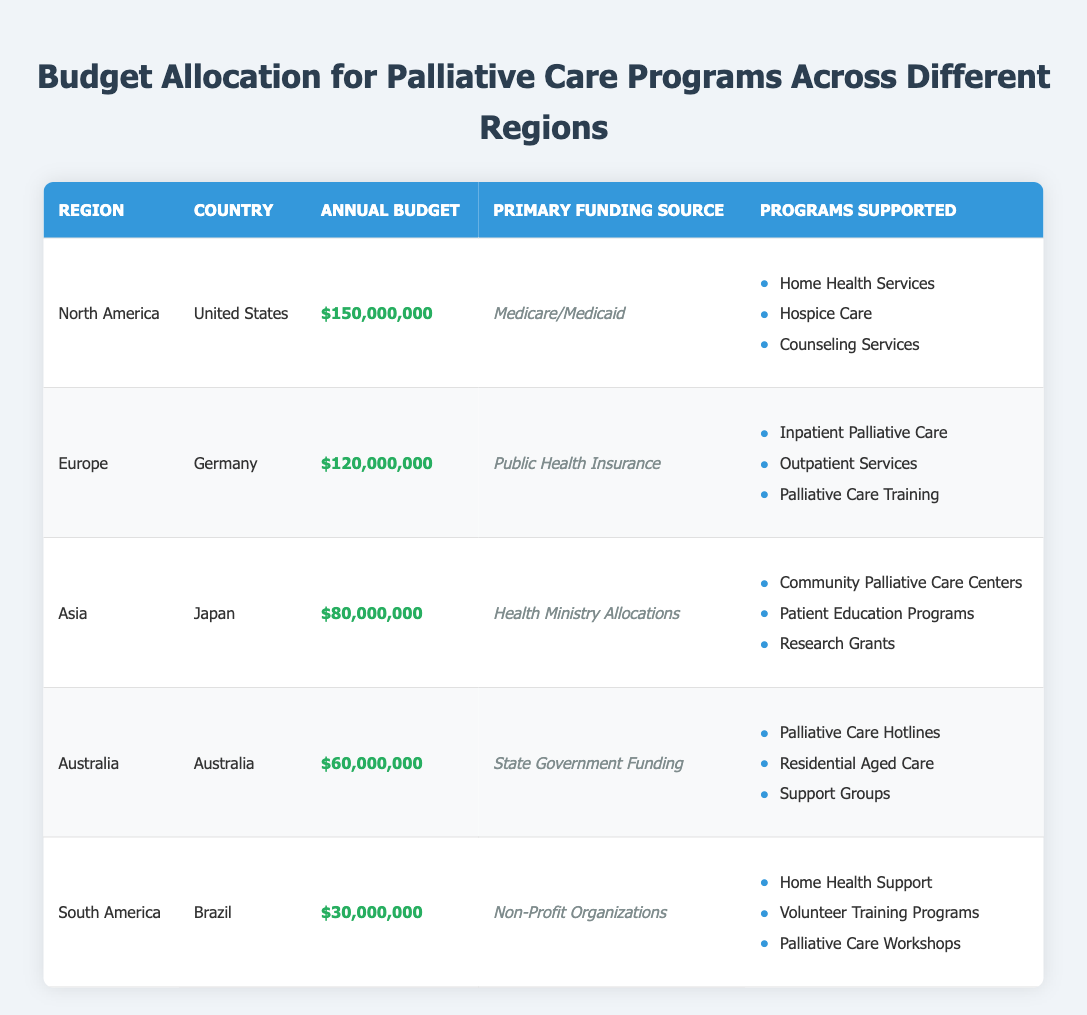What is the annual budget for palliative care programs in the United States? The table shows that the annual budget for palliative care programs in the United States is $150,000,000.
Answer: $150,000,000 Which country has the highest budget allocation for palliative care programs? By examining the annual budgets listed, the United States has the highest allocation at $150,000,000.
Answer: United States Is there any region where palliative care is funded by non-profit organizations? The table indicates that in South America (specifically Brazil), the primary funding source for palliative care programs is non-profit organizations.
Answer: Yes What is the total annual budget for palliative care programs in Europe? The annual budget for Germany is $120,000,000, which is the only entry for Europe in the table. Thus, the total is also $120,000,000.
Answer: $120,000,000 How much more budget is allocated to North America compared to South America? North America's budget is $150,000,000 and South America's budget is $30,000,000. The difference is $150,000,000 - $30,000,000 = $120,000,000.
Answer: $120,000,000 Which country provides programs focusing on community palliative care centers? The table indicates that Japan supports community palliative care centers as part of their programs.
Answer: Japan What is the combined annual budget for palliative care in Asia and Australia? Japan in Asia has a budget of $80,000,000, and Australia has a budget of $60,000,000. Adding these budgets gives $80,000,000 + $60,000,000 = $140,000,000.
Answer: $140,000,000 Can we say that all regions have a primary funding source that is government-related? The primary funding sources include Medicare/Medicaid, Public Health Insurance, and Health Ministry Allocations, which are all government-related; however, Brazil relies on non-profit organizations, indicating that not all are government-related.
Answer: No What proportion of the total budget is allocated to Japan? The total budget across all regions is $150,000,000 + $120,000,000 + $80,000,000 + $60,000,000 + $30,000,000 = $440,000,000. Japan's budget is $80,000,000. The proportion is $80,000,000 / $440,000,000 = 0.1818 or 18.18%.
Answer: 18.18% 